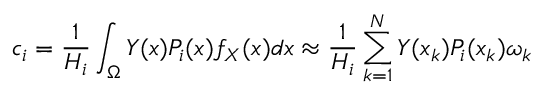<formula> <loc_0><loc_0><loc_500><loc_500>c _ { i } = \frac { 1 } { H _ { i } } \int _ { \Omega } Y ( x ) P _ { i } ( x ) f _ { X } ( x ) d x \approx \frac { 1 } { H _ { i } } \sum _ { k = 1 } ^ { N } Y ( x _ { k } ) P _ { i } ( x _ { k } ) \omega _ { k }</formula> 